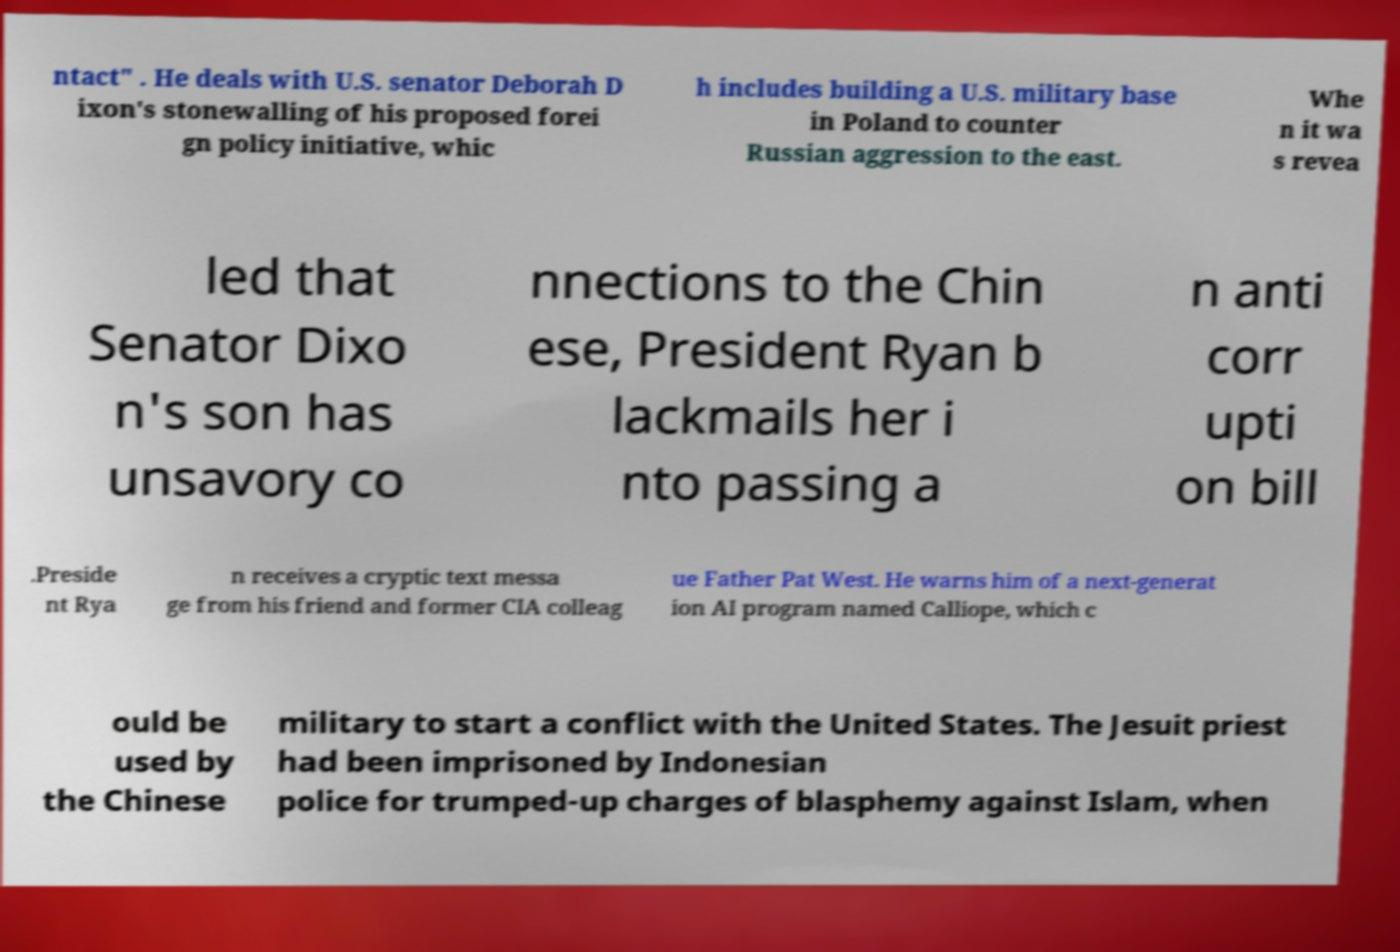Please read and relay the text visible in this image. What does it say? ntact" . He deals with U.S. senator Deborah D ixon's stonewalling of his proposed forei gn policy initiative, whic h includes building a U.S. military base in Poland to counter Russian aggression to the east. Whe n it wa s revea led that Senator Dixo n's son has unsavory co nnections to the Chin ese, President Ryan b lackmails her i nto passing a n anti corr upti on bill .Preside nt Rya n receives a cryptic text messa ge from his friend and former CIA colleag ue Father Pat West. He warns him of a next-generat ion AI program named Calliope, which c ould be used by the Chinese military to start a conflict with the United States. The Jesuit priest had been imprisoned by Indonesian police for trumped-up charges of blasphemy against Islam, when 